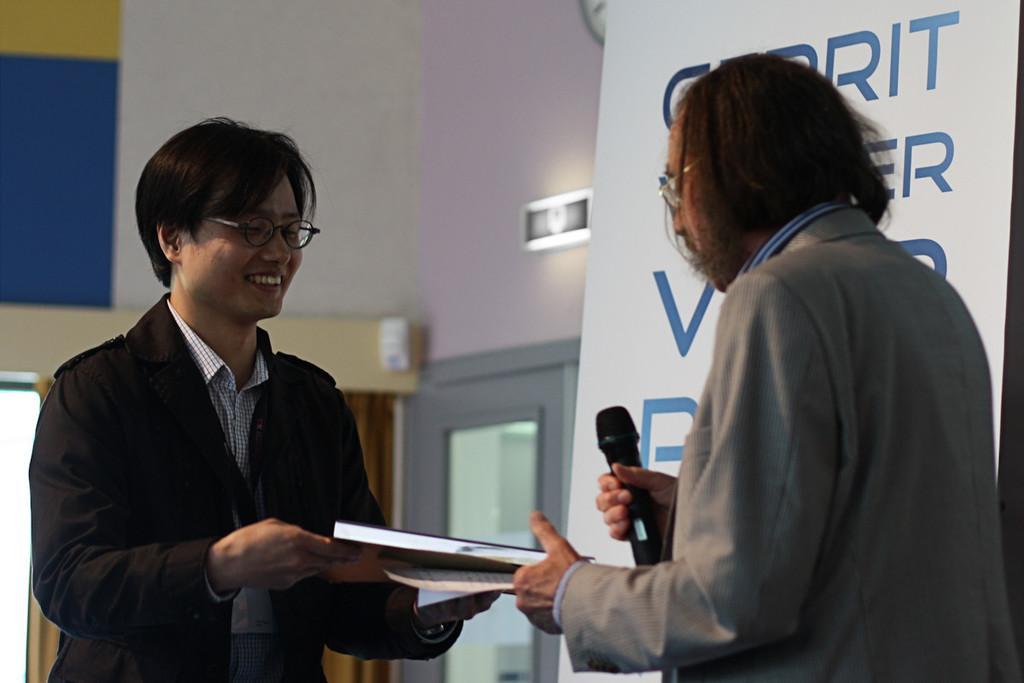Please provide a concise description of this image. In the picture I can see two persons are holding book and among them one person is holding microphone, side we can see banner and behind we can see door to the wall. 